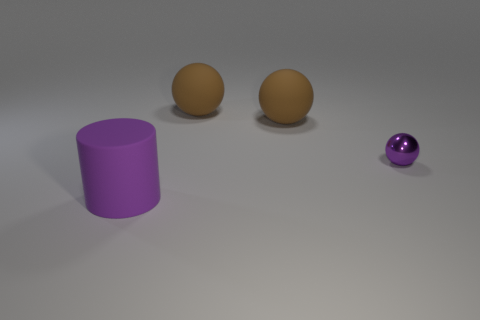Is there anything else that has the same size as the purple sphere?
Your response must be concise. No. How big is the thing in front of the purple object that is to the right of the purple object that is in front of the small sphere?
Make the answer very short. Large. Do the cylinder and the purple ball have the same size?
Provide a short and direct response. No. There is a purple thing that is right of the purple object that is left of the tiny purple metallic sphere; what is it made of?
Give a very brief answer. Metal. Is the shape of the purple thing that is behind the big purple matte thing the same as the large rubber thing in front of the small purple shiny thing?
Provide a short and direct response. No. Are there an equal number of tiny purple shiny spheres behind the big purple cylinder and purple metallic objects?
Offer a terse response. Yes. Are there any small purple metallic objects behind the purple object on the right side of the purple cylinder?
Your answer should be very brief. No. Are there any other things that are the same color as the small shiny thing?
Your answer should be very brief. Yes. Is the purple thing that is in front of the small purple sphere made of the same material as the purple ball?
Keep it short and to the point. No. Is the number of tiny balls to the right of the small sphere the same as the number of small purple balls in front of the big purple rubber thing?
Keep it short and to the point. Yes. 